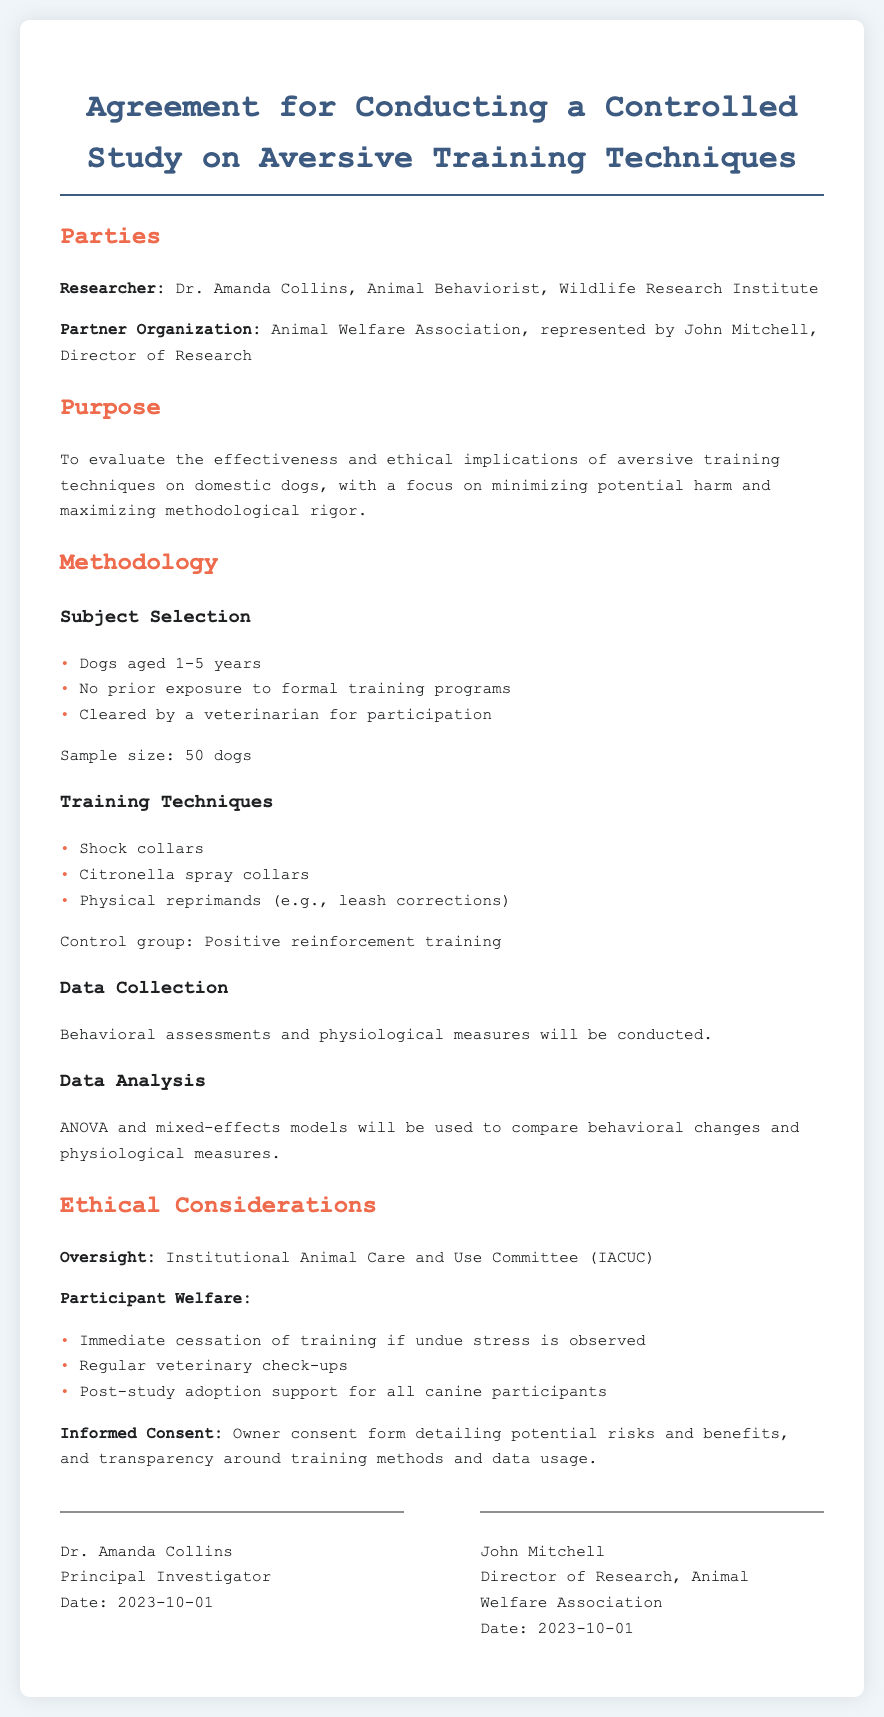What is the name of the principal investigator? The principal investigator is identified in the document as Dr. Amanda Collins.
Answer: Dr. Amanda Collins Who is the representative for the partner organization? The document states that the partner organization, Animal Welfare Association, is represented by John Mitchell.
Answer: John Mitchell What is the sample size of dogs participating in the study? The sample size mentioned in the methodology section is the number of dogs included in the study.
Answer: 50 dogs What are the three training techniques listed? The training techniques described in the document are listed in the methodology section.
Answer: Shock collars, Citronella spray collars, Physical reprimands What must the dogs be cleared by to participate in the study? The methodology specifies a requirement for the dogs to be cleared by a certain professional before participation.
Answer: Veterinarian Which committee provides oversight for the study? The ethical considerations section of the document identifies the committee responsible for oversight.
Answer: Institutional Animal Care and Use Committee (IACUC) What is the date when the deed was signed by the principal investigator? The signature section indicates the date the principal investigator signed the agreement.
Answer: 2023-10-01 What type of analysis will be used for data analysis? The methodology mentions specific statistical methods to be used for analyzing collected data.
Answer: ANOVA and mixed-effects models 